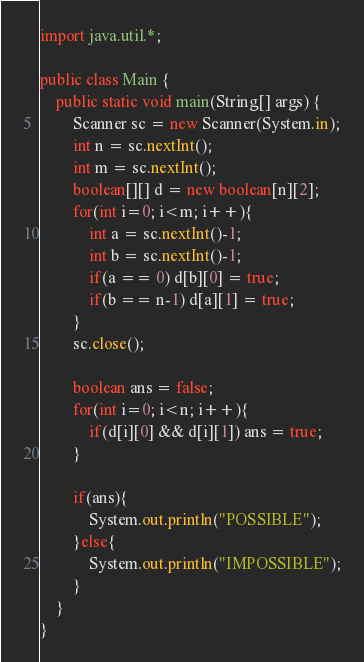<code> <loc_0><loc_0><loc_500><loc_500><_Java_>import java.util.*;

public class Main {
    public static void main(String[] args) {
        Scanner sc = new Scanner(System.in);
        int n = sc.nextInt();
        int m = sc.nextInt();
        boolean[][] d = new boolean[n][2];
        for(int i=0; i<m; i++){
            int a = sc.nextInt()-1;
            int b = sc.nextInt()-1;
            if(a == 0) d[b][0] = true;
            if(b == n-1) d[a][1] = true;
        }
        sc.close();

        boolean ans = false;
        for(int i=0; i<n; i++){
            if(d[i][0] && d[i][1]) ans = true;
        }

        if(ans){
            System.out.println("POSSIBLE");
        }else{
            System.out.println("IMPOSSIBLE");
        }
    }
}</code> 